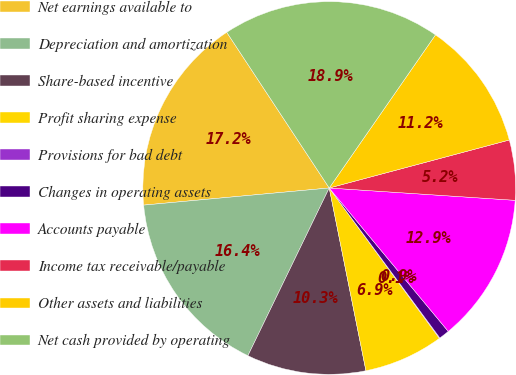Convert chart to OTSL. <chart><loc_0><loc_0><loc_500><loc_500><pie_chart><fcel>Net earnings available to<fcel>Depreciation and amortization<fcel>Share-based incentive<fcel>Profit sharing expense<fcel>Provisions for bad debt<fcel>Changes in operating assets<fcel>Accounts payable<fcel>Income tax receivable/payable<fcel>Other assets and liabilities<fcel>Net cash provided by operating<nl><fcel>17.2%<fcel>16.35%<fcel>10.34%<fcel>6.91%<fcel>0.05%<fcel>0.91%<fcel>12.92%<fcel>5.2%<fcel>11.2%<fcel>18.92%<nl></chart> 